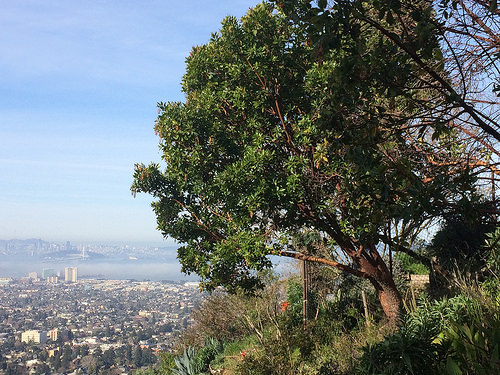<image>
Is the tree behind the fence? No. The tree is not behind the fence. From this viewpoint, the tree appears to be positioned elsewhere in the scene. 